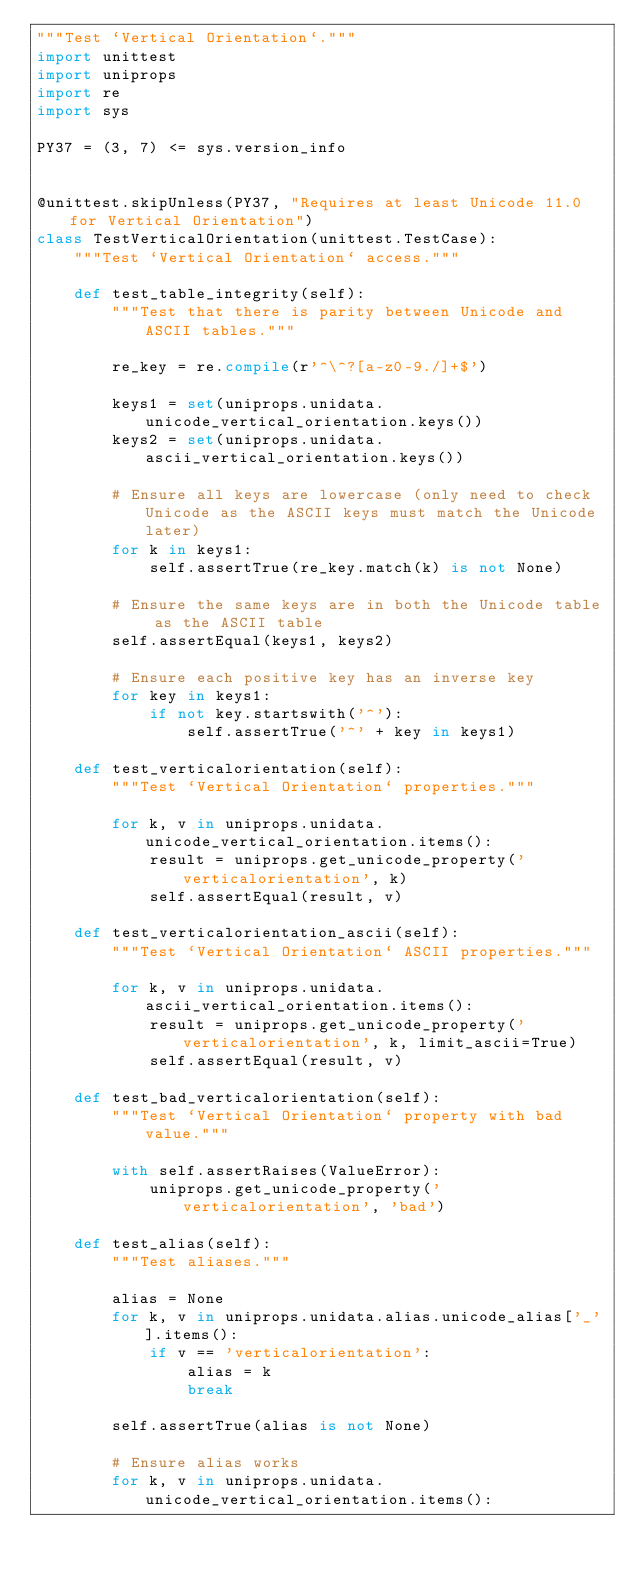<code> <loc_0><loc_0><loc_500><loc_500><_Python_>"""Test `Vertical Orientation`."""
import unittest
import uniprops
import re
import sys

PY37 = (3, 7) <= sys.version_info


@unittest.skipUnless(PY37, "Requires at least Unicode 11.0 for Vertical Orientation")
class TestVerticalOrientation(unittest.TestCase):
    """Test `Vertical Orientation` access."""

    def test_table_integrity(self):
        """Test that there is parity between Unicode and ASCII tables."""

        re_key = re.compile(r'^\^?[a-z0-9./]+$')

        keys1 = set(uniprops.unidata.unicode_vertical_orientation.keys())
        keys2 = set(uniprops.unidata.ascii_vertical_orientation.keys())

        # Ensure all keys are lowercase (only need to check Unicode as the ASCII keys must match the Unicode later)
        for k in keys1:
            self.assertTrue(re_key.match(k) is not None)

        # Ensure the same keys are in both the Unicode table as the ASCII table
        self.assertEqual(keys1, keys2)

        # Ensure each positive key has an inverse key
        for key in keys1:
            if not key.startswith('^'):
                self.assertTrue('^' + key in keys1)

    def test_verticalorientation(self):
        """Test `Vertical Orientation` properties."""

        for k, v in uniprops.unidata.unicode_vertical_orientation.items():
            result = uniprops.get_unicode_property('verticalorientation', k)
            self.assertEqual(result, v)

    def test_verticalorientation_ascii(self):
        """Test `Vertical Orientation` ASCII properties."""

        for k, v in uniprops.unidata.ascii_vertical_orientation.items():
            result = uniprops.get_unicode_property('verticalorientation', k, limit_ascii=True)
            self.assertEqual(result, v)

    def test_bad_verticalorientation(self):
        """Test `Vertical Orientation` property with bad value."""

        with self.assertRaises(ValueError):
            uniprops.get_unicode_property('verticalorientation', 'bad')

    def test_alias(self):
        """Test aliases."""

        alias = None
        for k, v in uniprops.unidata.alias.unicode_alias['_'].items():
            if v == 'verticalorientation':
                alias = k
                break

        self.assertTrue(alias is not None)

        # Ensure alias works
        for k, v in uniprops.unidata.unicode_vertical_orientation.items():</code> 